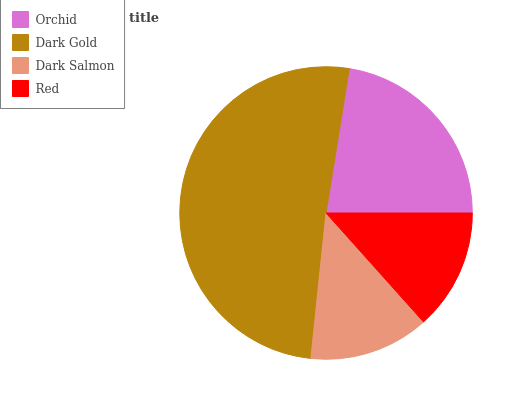Is Dark Salmon the minimum?
Answer yes or no. Yes. Is Dark Gold the maximum?
Answer yes or no. Yes. Is Dark Gold the minimum?
Answer yes or no. No. Is Dark Salmon the maximum?
Answer yes or no. No. Is Dark Gold greater than Dark Salmon?
Answer yes or no. Yes. Is Dark Salmon less than Dark Gold?
Answer yes or no. Yes. Is Dark Salmon greater than Dark Gold?
Answer yes or no. No. Is Dark Gold less than Dark Salmon?
Answer yes or no. No. Is Orchid the high median?
Answer yes or no. Yes. Is Red the low median?
Answer yes or no. Yes. Is Dark Salmon the high median?
Answer yes or no. No. Is Dark Salmon the low median?
Answer yes or no. No. 